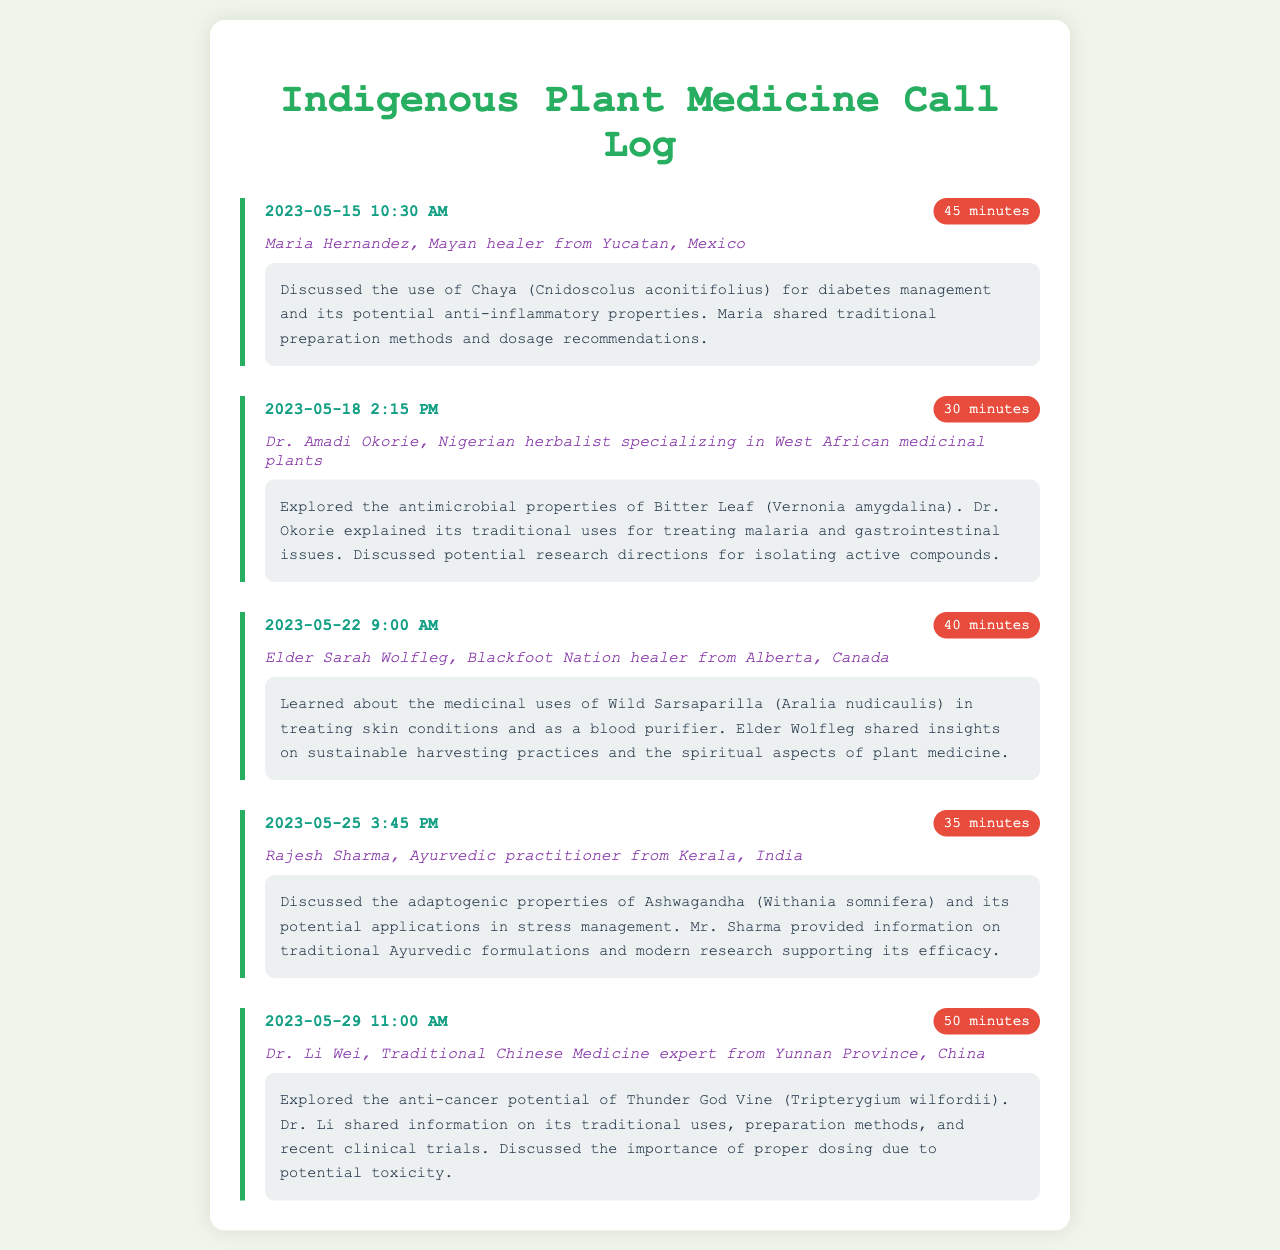What date did the call with Maria Hernandez take place? The call with Maria Hernandez occurred on the date mentioned in the first call log, which is specified as 2023-05-15.
Answer: 2023-05-15 Who is the healer mentioned in the second call? The second call features Dr. Amadi Okorie, a Nigerian herbalist specializing in West African medicinal plants.
Answer: Dr. Amadi Okorie What is the duration of the call with Elder Sarah Wolfleg? The duration of the call with Elder Sarah Wolfleg is recorded in the third call log as 40 minutes.
Answer: 40 minutes Which plant is associated with the anti-cancer potential discussed by Dr. Li Wei? The plant associated with anti-cancer potential in the conversation with Dr. Li Wei is Thunder God Vine.
Answer: Thunder God Vine What was discussed regarding Ashwagandha in the call with Rajesh Sharma? The discussion on Ashwagandha focused on its adaptogenic properties and potential applications in stress management.
Answer: Adaptogenic properties How many minutes was the longest call recorded in the log? The longest call duration can be found in the call log with Dr. Li Wei, which lasted 50 minutes.
Answer: 50 minutes What traditional use for Bitter Leaf did Dr. Okorie explain? Dr. Okorie explained the traditional uses of Bitter Leaf for treating malaria and gastrointestinal issues.
Answer: Treating malaria What is the common theme of the calls recorded in this log? The common theme revolves around discussions on traditional plant remedies and their medicinal properties.
Answer: Traditional plant remedies 